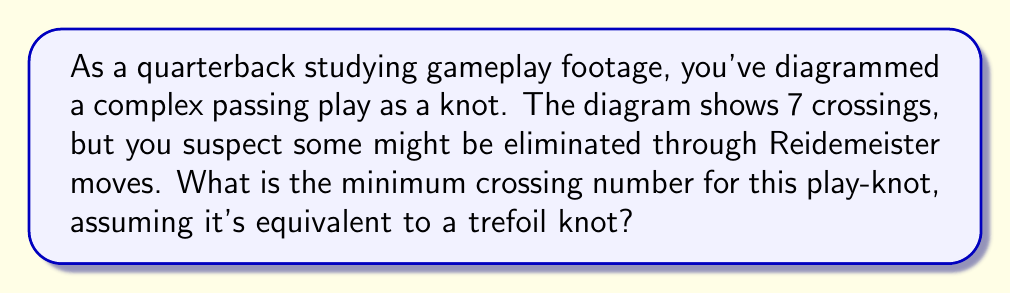Show me your answer to this math problem. To solve this problem, let's follow these steps:

1) First, recall that the trefoil knot is one of the simplest non-trivial knots in knot theory. It's important to know that the trefoil knot has a crossing number of 3.

2) The crossing number of a knot is defined as the minimum number of crossings that occur in any diagram of the knot. It's denoted by $c(K)$ for a knot $K$.

3) In this case, we're told that the play diagram shows 7 crossings initially. However, we're also told that it's equivalent to a trefoil knot. This means that through a series of Reidemeister moves, we should be able to reduce the number of crossings to that of a trefoil knot.

4) The Reidemeister moves are a set of three local moves on a knot diagram that can be used to change the diagram without changing the underlying knot. These moves allow us to simplify knot diagrams without changing the knot type.

5) Given that our play-knot is equivalent to a trefoil knot, we know that no matter how complex the initial diagram looks, it must be possible to reduce it to a diagram with only 3 crossings.

6) Therefore, the minimum crossing number for this play-knot is the same as the crossing number of a trefoil knot:

   $$c(K) = c(\text{trefoil}) = 3$$

This means that while the initial play diagram may look complex with 7 crossings, it can be simplified to show its true structure as a trefoil knot with only 3 essential crossings.
Answer: 3 